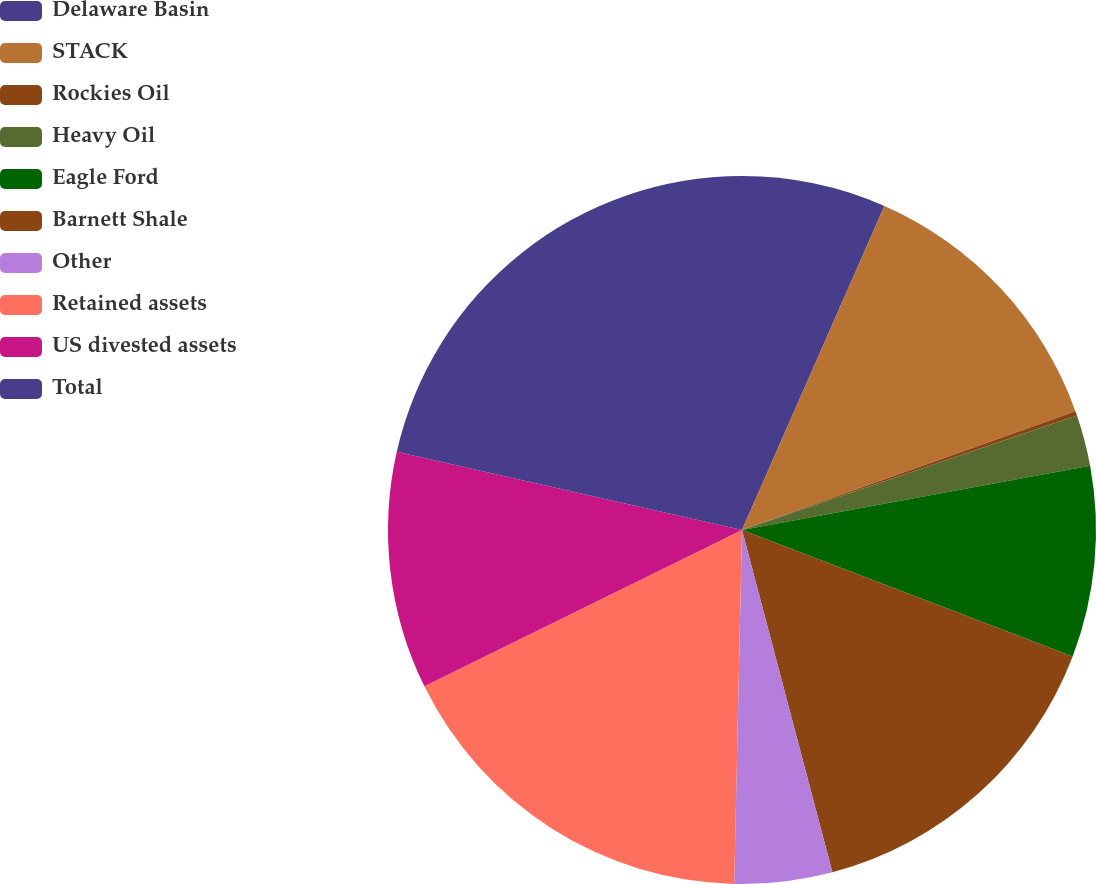<chart> <loc_0><loc_0><loc_500><loc_500><pie_chart><fcel>Delaware Basin<fcel>STACK<fcel>Rockies Oil<fcel>Heavy Oil<fcel>Eagle Ford<fcel>Barnett Shale<fcel>Other<fcel>Retained assets<fcel>US divested assets<fcel>Total<nl><fcel>6.59%<fcel>12.96%<fcel>0.21%<fcel>2.34%<fcel>8.71%<fcel>15.08%<fcel>4.46%<fcel>17.37%<fcel>10.83%<fcel>21.45%<nl></chart> 